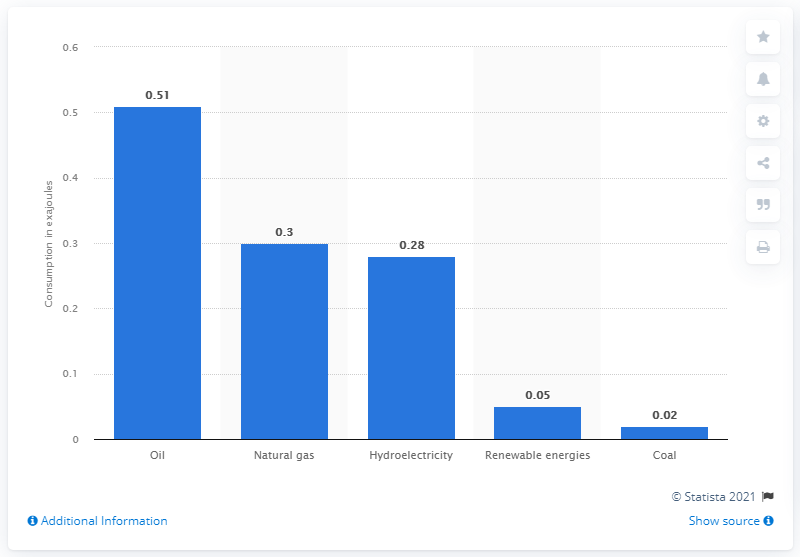Point out several critical features in this image. In 2019, hydroelectricity was the third largest source of energy consumption in Peru. 